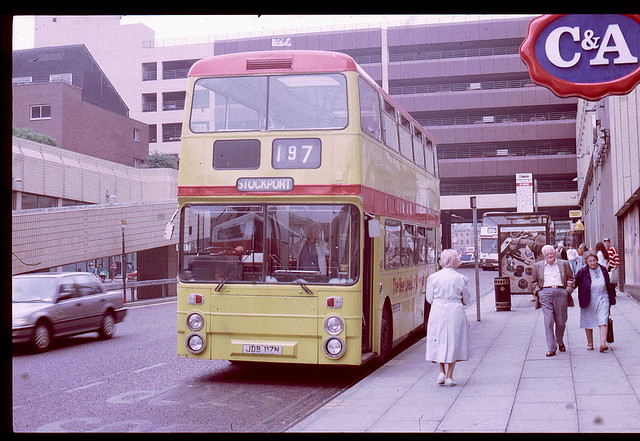Please extract the text content from this image. 197 STOCKPORT JDB 117N A & C 